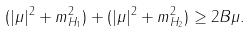Convert formula to latex. <formula><loc_0><loc_0><loc_500><loc_500>( | \mu | ^ { 2 } + m _ { H _ { 1 } } ^ { 2 } ) + ( | \mu | ^ { 2 } + m _ { H _ { 2 } } ^ { 2 } ) \geq 2 B \mu .</formula> 